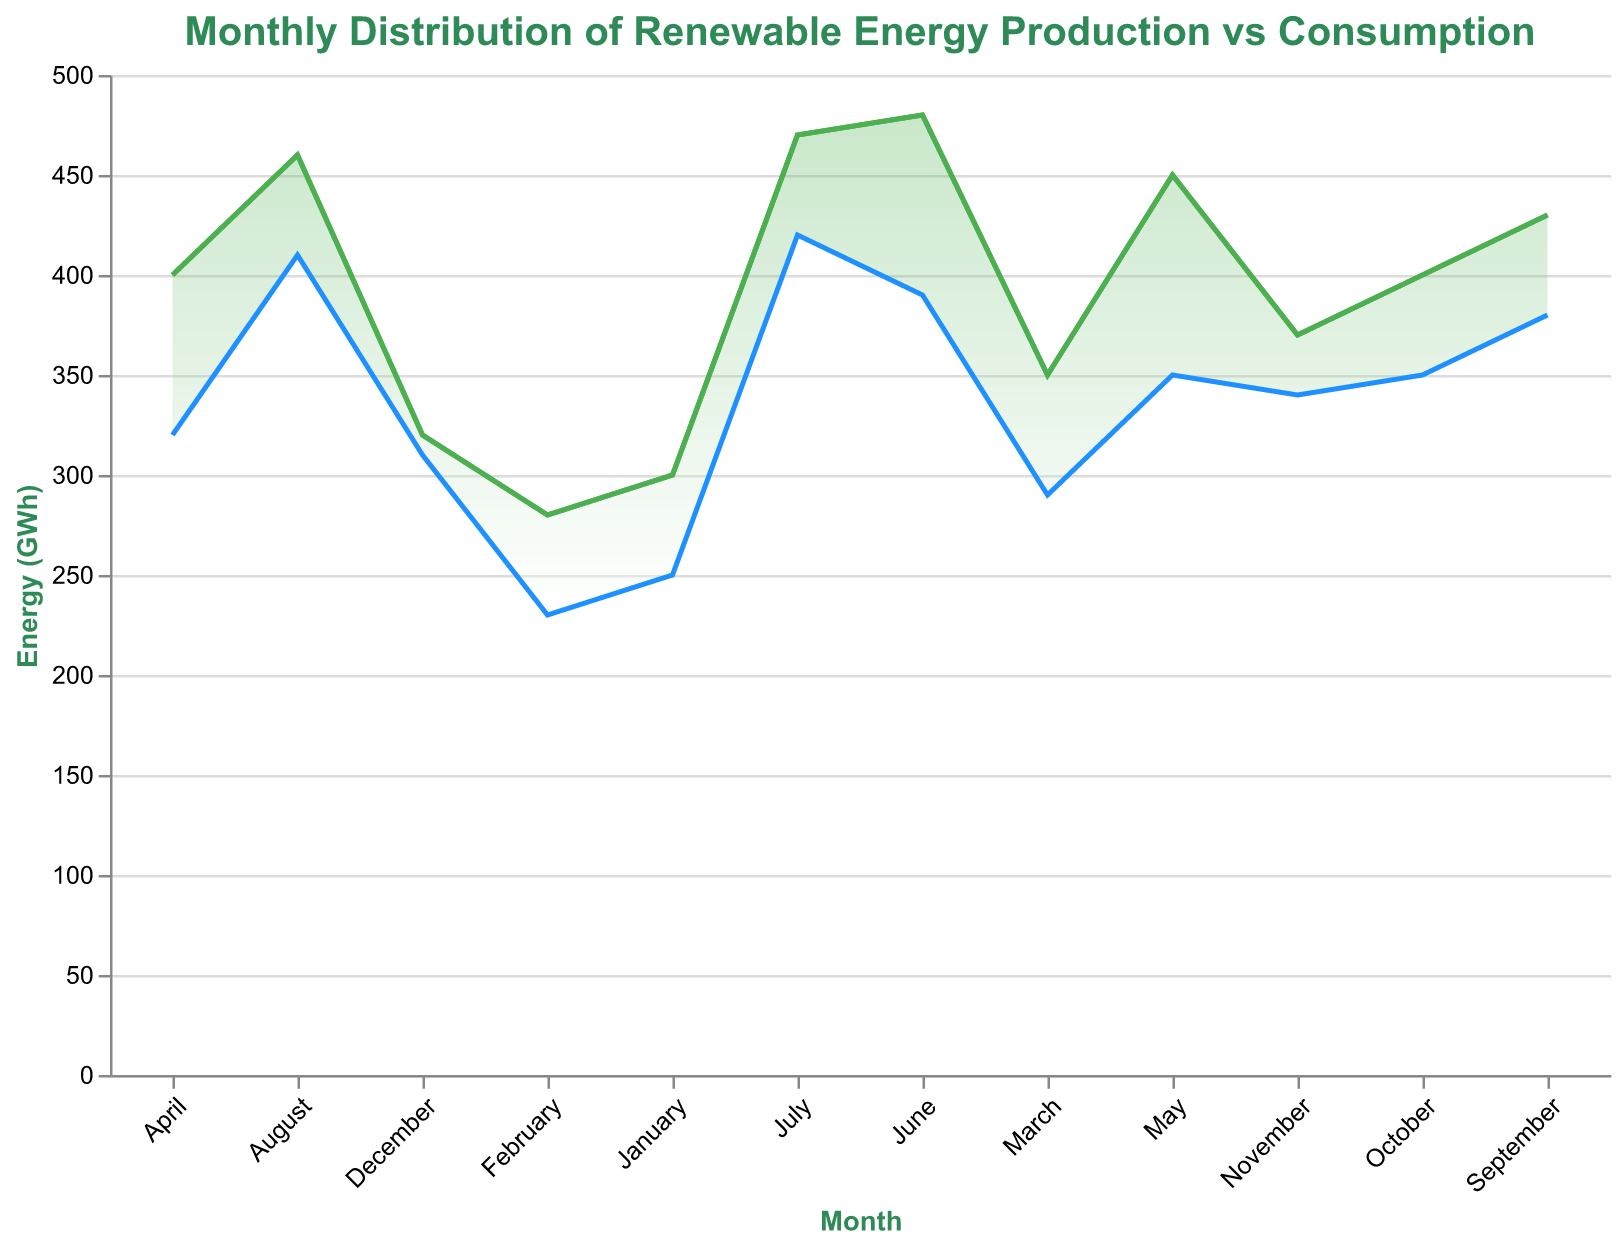What does the title of the chart say? The title is typically found at the top of the chart and provides a brief description of what the chart represents.
Answer: Monthly Distribution of Renewable Energy Production vs Consumption What are the two colors used to represent the lines on the chart? Observing the chart, there are typically two lines, each with a distinct color. One of the lines is green, and the other is blue.
Answer: Green and blue How many months are represented in the chart? The chart represents data points for each month in a year, so there are 12 months total.
Answer: Twelve In which month is the difference between renewable energy production and consumption the greatest? Looking at the vertical distance between the green and blue lines, June shows the largest gap, where production is 480 GWh and consumption is 390 GWh. So the difference is 480 - 390 = 90 GWh.
Answer: June What is the renewable energy consumption in December? The blue line (representing consumption) and the y-axis coordinate for December show that consumption is 310 GWh.
Answer: 310 GWh During which month is renewable energy production the highest? The green line peaks in June at 480 GWh, the highest point on the entire chart.
Answer: June How does the renewable consumption in January compare to the renewable production in January? Look at January's data: Renewable Production is 300 GWh, and Renewable Consumption is 250 GWh. Production is higher than consumption by 50 GWh.
Answer: Renewable Production is 50 GWh higher What is the average renewable energy production for the first quarter (January to March)? Sum the production values for January, February, and March: 300 + 280 + 350 = 930 GWh. Then divide by 3 (number of months in the quarter) to find the average: 930 / 3 = 310 GWh.
Answer: 310 GWh Compare the total renewable energy produced in the second half of the year (July to December) with the first half (January to June). Which half of the year produced more energy? Sum the production values for each half: First half is 300 + 280 + 350 + 400 + 450 + 480 = 2260 GWh and the second half is 470 + 460 + 430 + 400 + 370 + 320 = 2450 GWh. The second half produced more energy.
Answer: Second half What does the shaded area between the production and consumption lines represent? The shaded area in a range area chart typically represents the gap between two datasets, in this case, the difference between renewable energy production and consumption over time.
Answer: The gap between production and consumption 